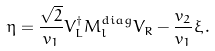<formula> <loc_0><loc_0><loc_500><loc_500>\eta = \frac { \sqrt { 2 } } { v _ { 1 } } V _ { L } ^ { \dag } M _ { l } ^ { d i a g } V _ { R } - \frac { v _ { 2 } } { v _ { 1 } } \xi \, .</formula> 